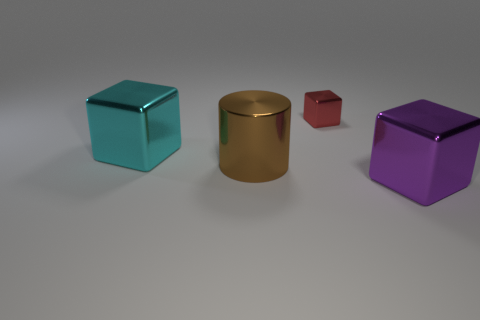Is the number of small red objects less than the number of big metallic objects? Yes, upon careful observation, the number of small red objects, which amounts to only one small red cube, is indeed less than the number of big metallic objects, as there appears to be one large metallic cylinder present. 